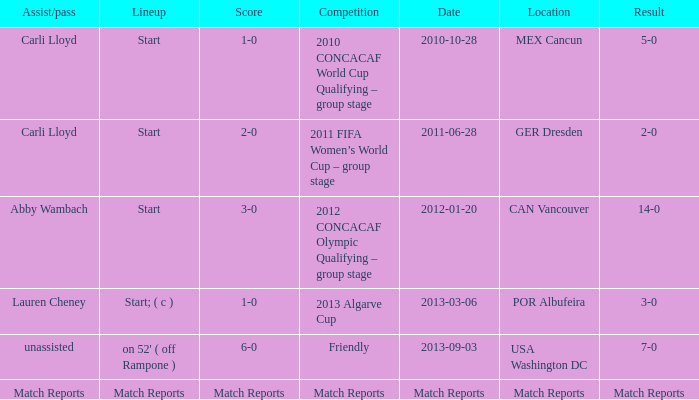Which score has a location of mex cancun? 1-0. 